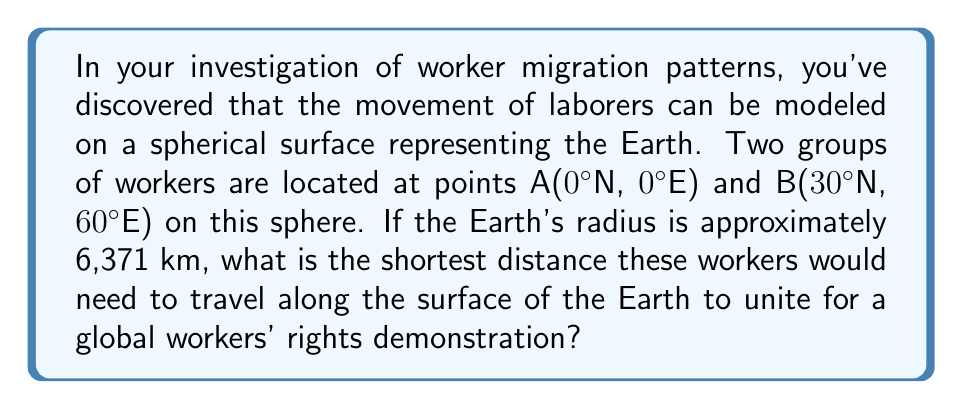Teach me how to tackle this problem. To solve this problem, we need to use the formula for geodesic distance on a sphere, also known as the great-circle distance. The steps are as follows:

1) The formula for geodesic distance on a sphere is:

   $$d = R \cdot \arccos(\sin\phi_1 \sin\phi_2 + \cos\phi_1 \cos\phi_2 \cos(\Delta\lambda))$$

   Where:
   - $d$ is the distance
   - $R$ is the radius of the sphere
   - $\phi_1$ and $\phi_2$ are the latitudes of the two points
   - $\Delta\lambda$ is the absolute difference in longitude

2) Convert the given coordinates to radians:
   - A(0°N, 0°E): $\phi_1 = 0$, $\lambda_1 = 0$
   - B(30°N, 60°E): $\phi_2 = \frac{\pi}{6}$, $\lambda_2 = \frac{\pi}{3}$

3) Calculate $\Delta\lambda$:
   $\Delta\lambda = |\lambda_2 - \lambda_1| = |\frac{\pi}{3} - 0| = \frac{\pi}{3}$

4) Substitute these values into the formula:

   $$d = 6371 \cdot \arccos(\sin(0) \sin(\frac{\pi}{6}) + \cos(0) \cos(\frac{\pi}{6}) \cos(\frac{\pi}{3}))$$

5) Simplify:
   $$d = 6371 \cdot \arccos(0 + \frac{\sqrt{3}}{2} \cdot \frac{1}{2})$$
   $$d = 6371 \cdot \arccos(\frac{\sqrt{3}}{4})$$

6) Calculate the result:
   $$d \approx 6371 \cdot 1.159 \approx 7384.189 \text{ km}$$
Answer: 7384.189 km 